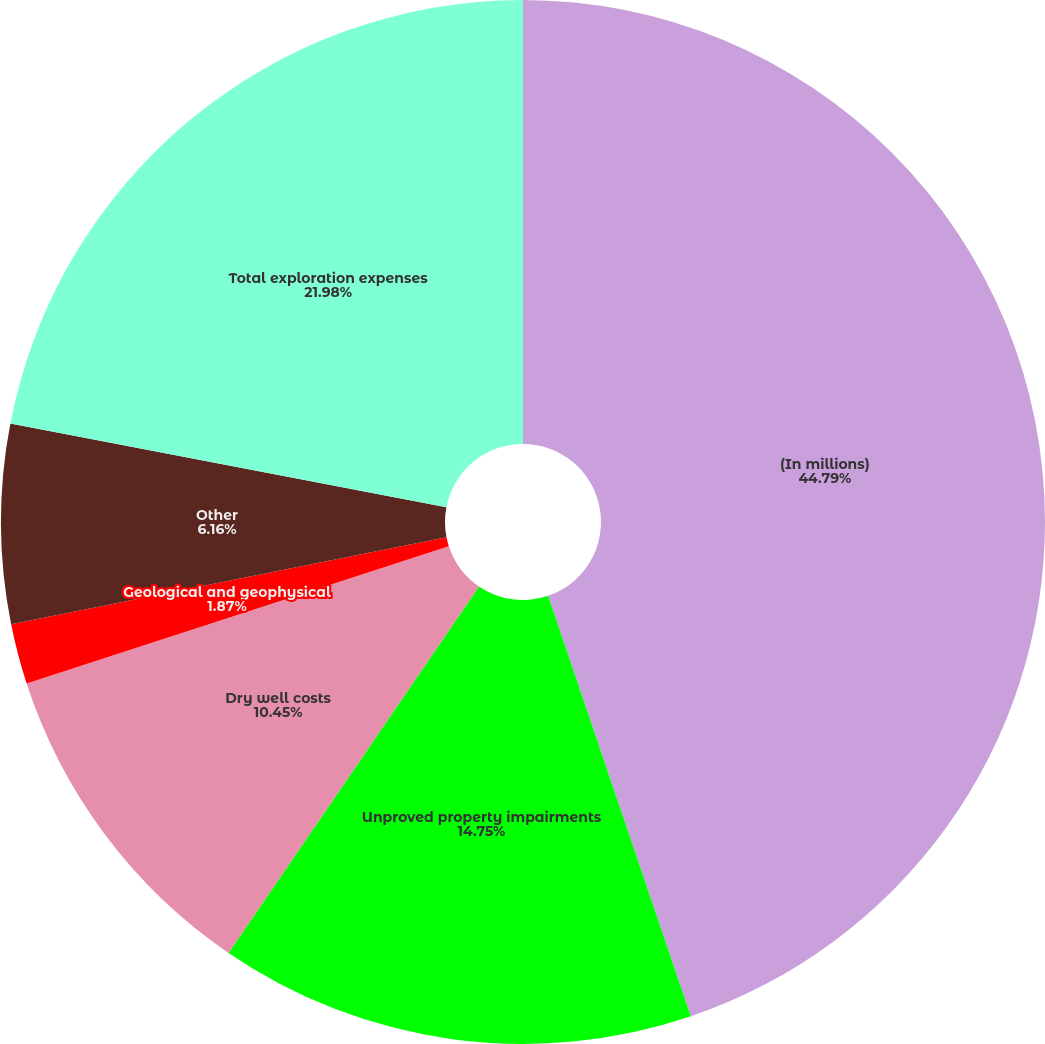Convert chart. <chart><loc_0><loc_0><loc_500><loc_500><pie_chart><fcel>(In millions)<fcel>Unproved property impairments<fcel>Dry well costs<fcel>Geological and geophysical<fcel>Other<fcel>Total exploration expenses<nl><fcel>44.79%<fcel>14.75%<fcel>10.45%<fcel>1.87%<fcel>6.16%<fcel>21.98%<nl></chart> 